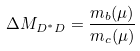Convert formula to latex. <formula><loc_0><loc_0><loc_500><loc_500>\Delta M _ { D ^ { * } D } = { \frac { m _ { b } ( \mu ) } { m _ { c } ( \mu ) } }</formula> 